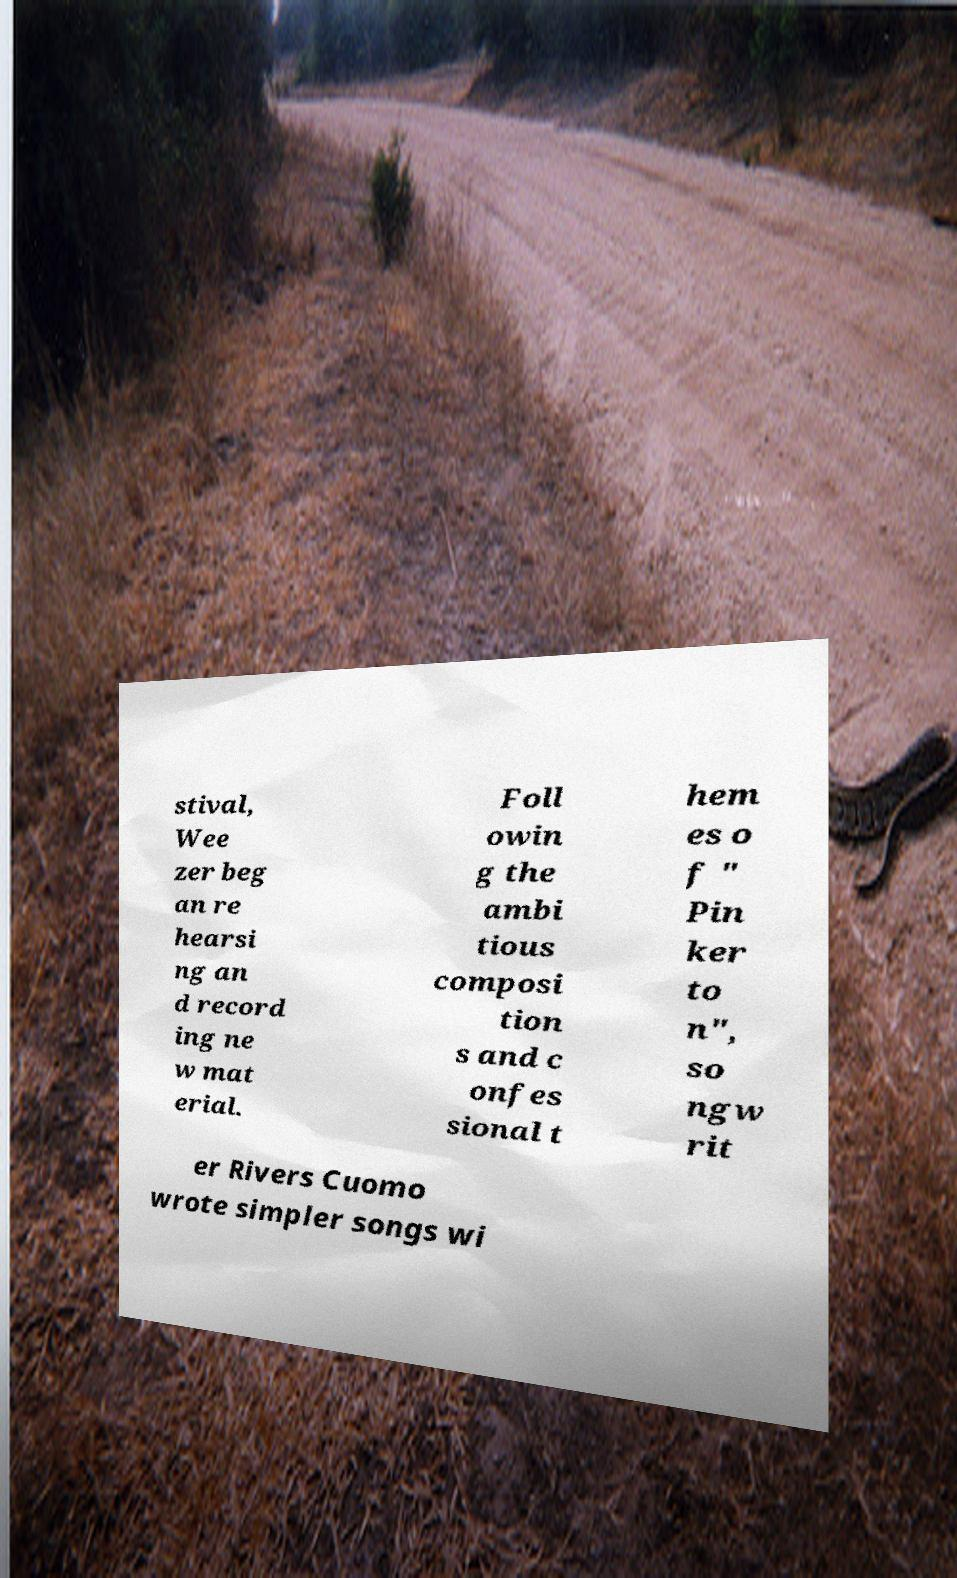Can you accurately transcribe the text from the provided image for me? stival, Wee zer beg an re hearsi ng an d record ing ne w mat erial. Foll owin g the ambi tious composi tion s and c onfes sional t hem es o f " Pin ker to n", so ngw rit er Rivers Cuomo wrote simpler songs wi 